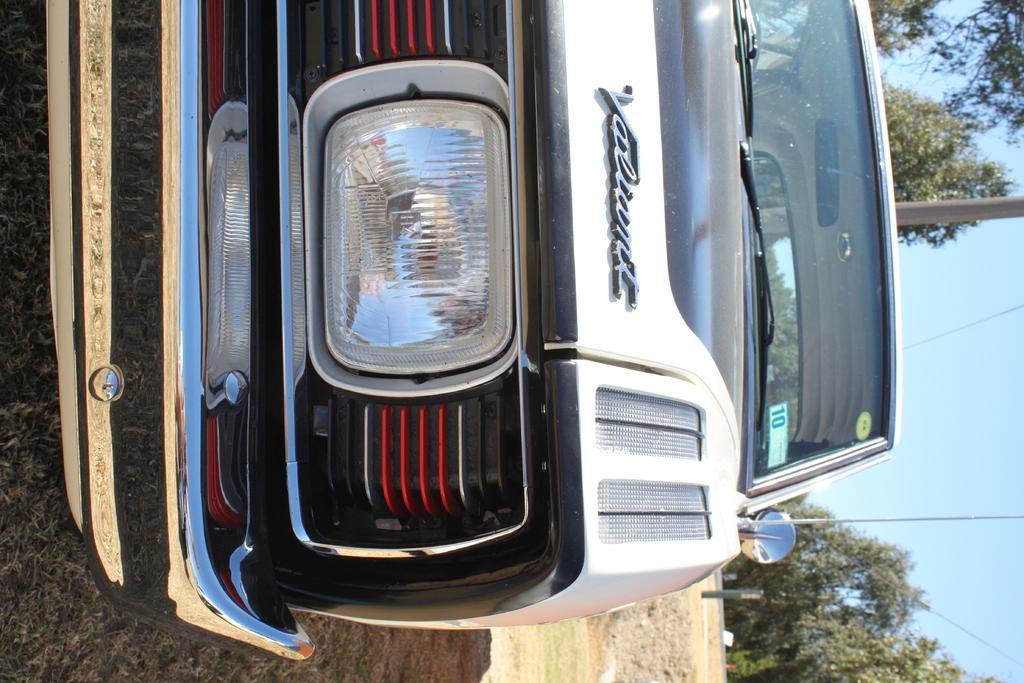What is the main subject of the image? The main subject of the image is a car. What specific features can be seen on the car? The car has a headlight and a front bumper. What can be seen in the background of the image? There are poles, trees, and the sky visible in the background of the image. What type of hospital is located near the car in the image? There is no hospital present in the image; it only features a car and the background elements. What is the current temperature in the image? The image does not provide any information about the temperature; it only shows a car and the background. 